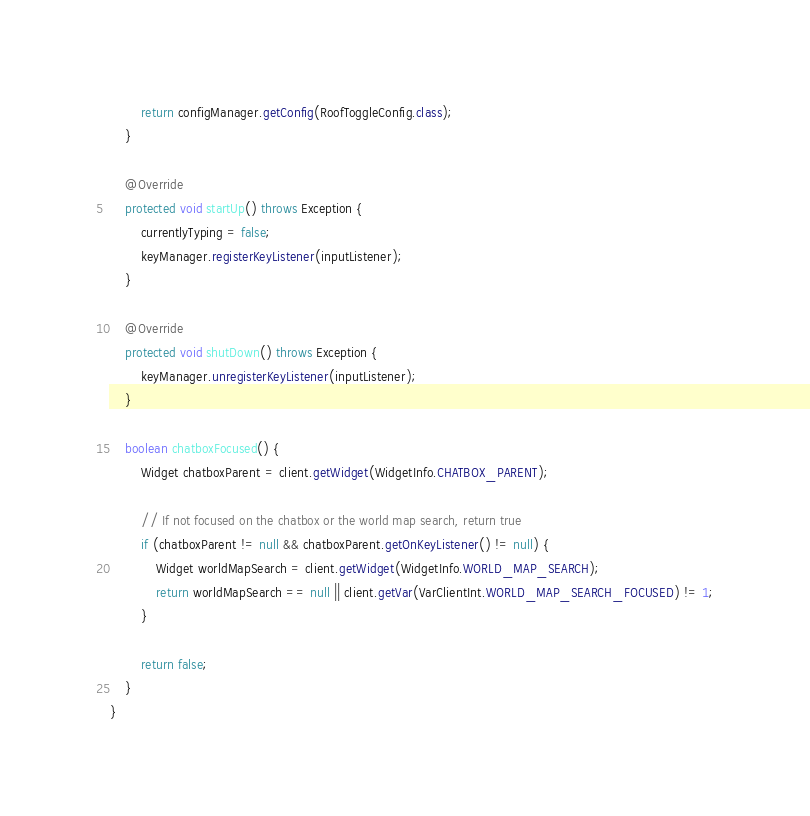Convert code to text. <code><loc_0><loc_0><loc_500><loc_500><_Java_>        return configManager.getConfig(RoofToggleConfig.class);
    }

    @Override
    protected void startUp() throws Exception {
        currentlyTyping = false;
        keyManager.registerKeyListener(inputListener);
    }

    @Override
    protected void shutDown() throws Exception {
        keyManager.unregisterKeyListener(inputListener);
    }

    boolean chatboxFocused() {
        Widget chatboxParent = client.getWidget(WidgetInfo.CHATBOX_PARENT);

        // If not focused on the chatbox or the world map search, return true
        if (chatboxParent != null && chatboxParent.getOnKeyListener() != null) {
            Widget worldMapSearch = client.getWidget(WidgetInfo.WORLD_MAP_SEARCH);
            return worldMapSearch == null || client.getVar(VarClientInt.WORLD_MAP_SEARCH_FOCUSED) != 1;
        }

        return false;
    }
}
</code> 